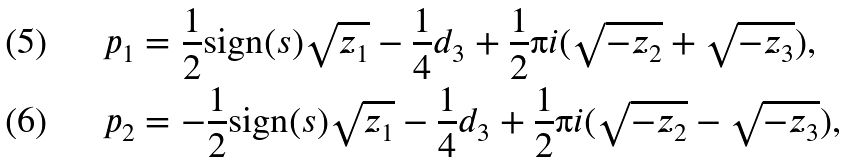Convert formula to latex. <formula><loc_0><loc_0><loc_500><loc_500>& p _ { 1 } = \frac { 1 } { 2 } \text {sign} ( s ) \sqrt { z _ { 1 } } - \frac { 1 } { 4 } d _ { 3 } + \frac { 1 } { 2 } \i i ( \sqrt { - z _ { 2 } } + \sqrt { - z _ { 3 } } ) , \\ & p _ { 2 } = - \frac { 1 } { 2 } \text {sign} ( s ) \sqrt { z _ { 1 } } - \frac { 1 } { 4 } d _ { 3 } + \frac { 1 } { 2 } \i i ( \sqrt { - z _ { 2 } } - \sqrt { - z _ { 3 } } ) ,</formula> 